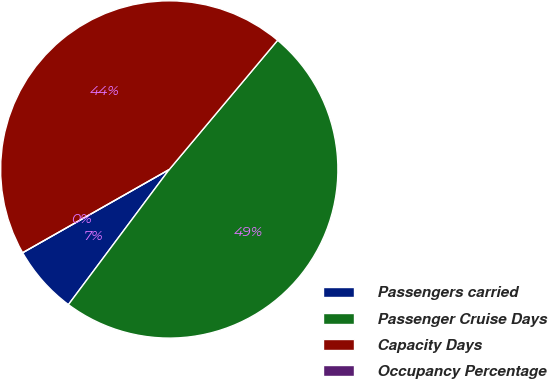Convert chart. <chart><loc_0><loc_0><loc_500><loc_500><pie_chart><fcel>Passengers carried<fcel>Passenger Cruise Days<fcel>Capacity Days<fcel>Occupancy Percentage<nl><fcel>6.58%<fcel>49.1%<fcel>44.33%<fcel>0.0%<nl></chart> 